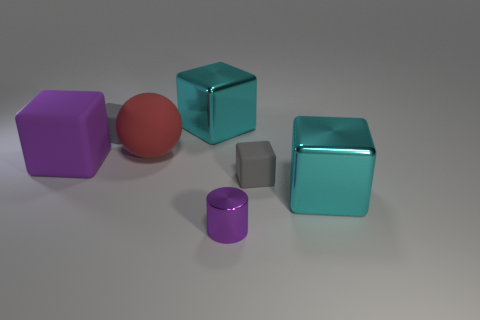Can you guess the approximate size of these objects based on their appearance? It's tricky to provide an accurate estimate without a reference object for scale; however, given their appearance and the context they are presented in, they might be approximately the size of standard building blocks used by children for play. 